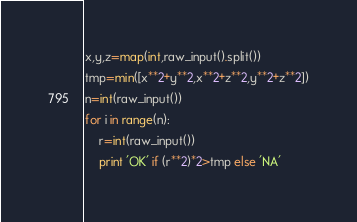Convert code to text. <code><loc_0><loc_0><loc_500><loc_500><_Python_>x,y,z=map(int,raw_input().split())
tmp=min([x**2+y**2,x**2+z**2,y**2+z**2])
n=int(raw_input())
for i in range(n):
    r=int(raw_input())
    print 'OK' if (r**2)*2>tmp else 'NA'</code> 